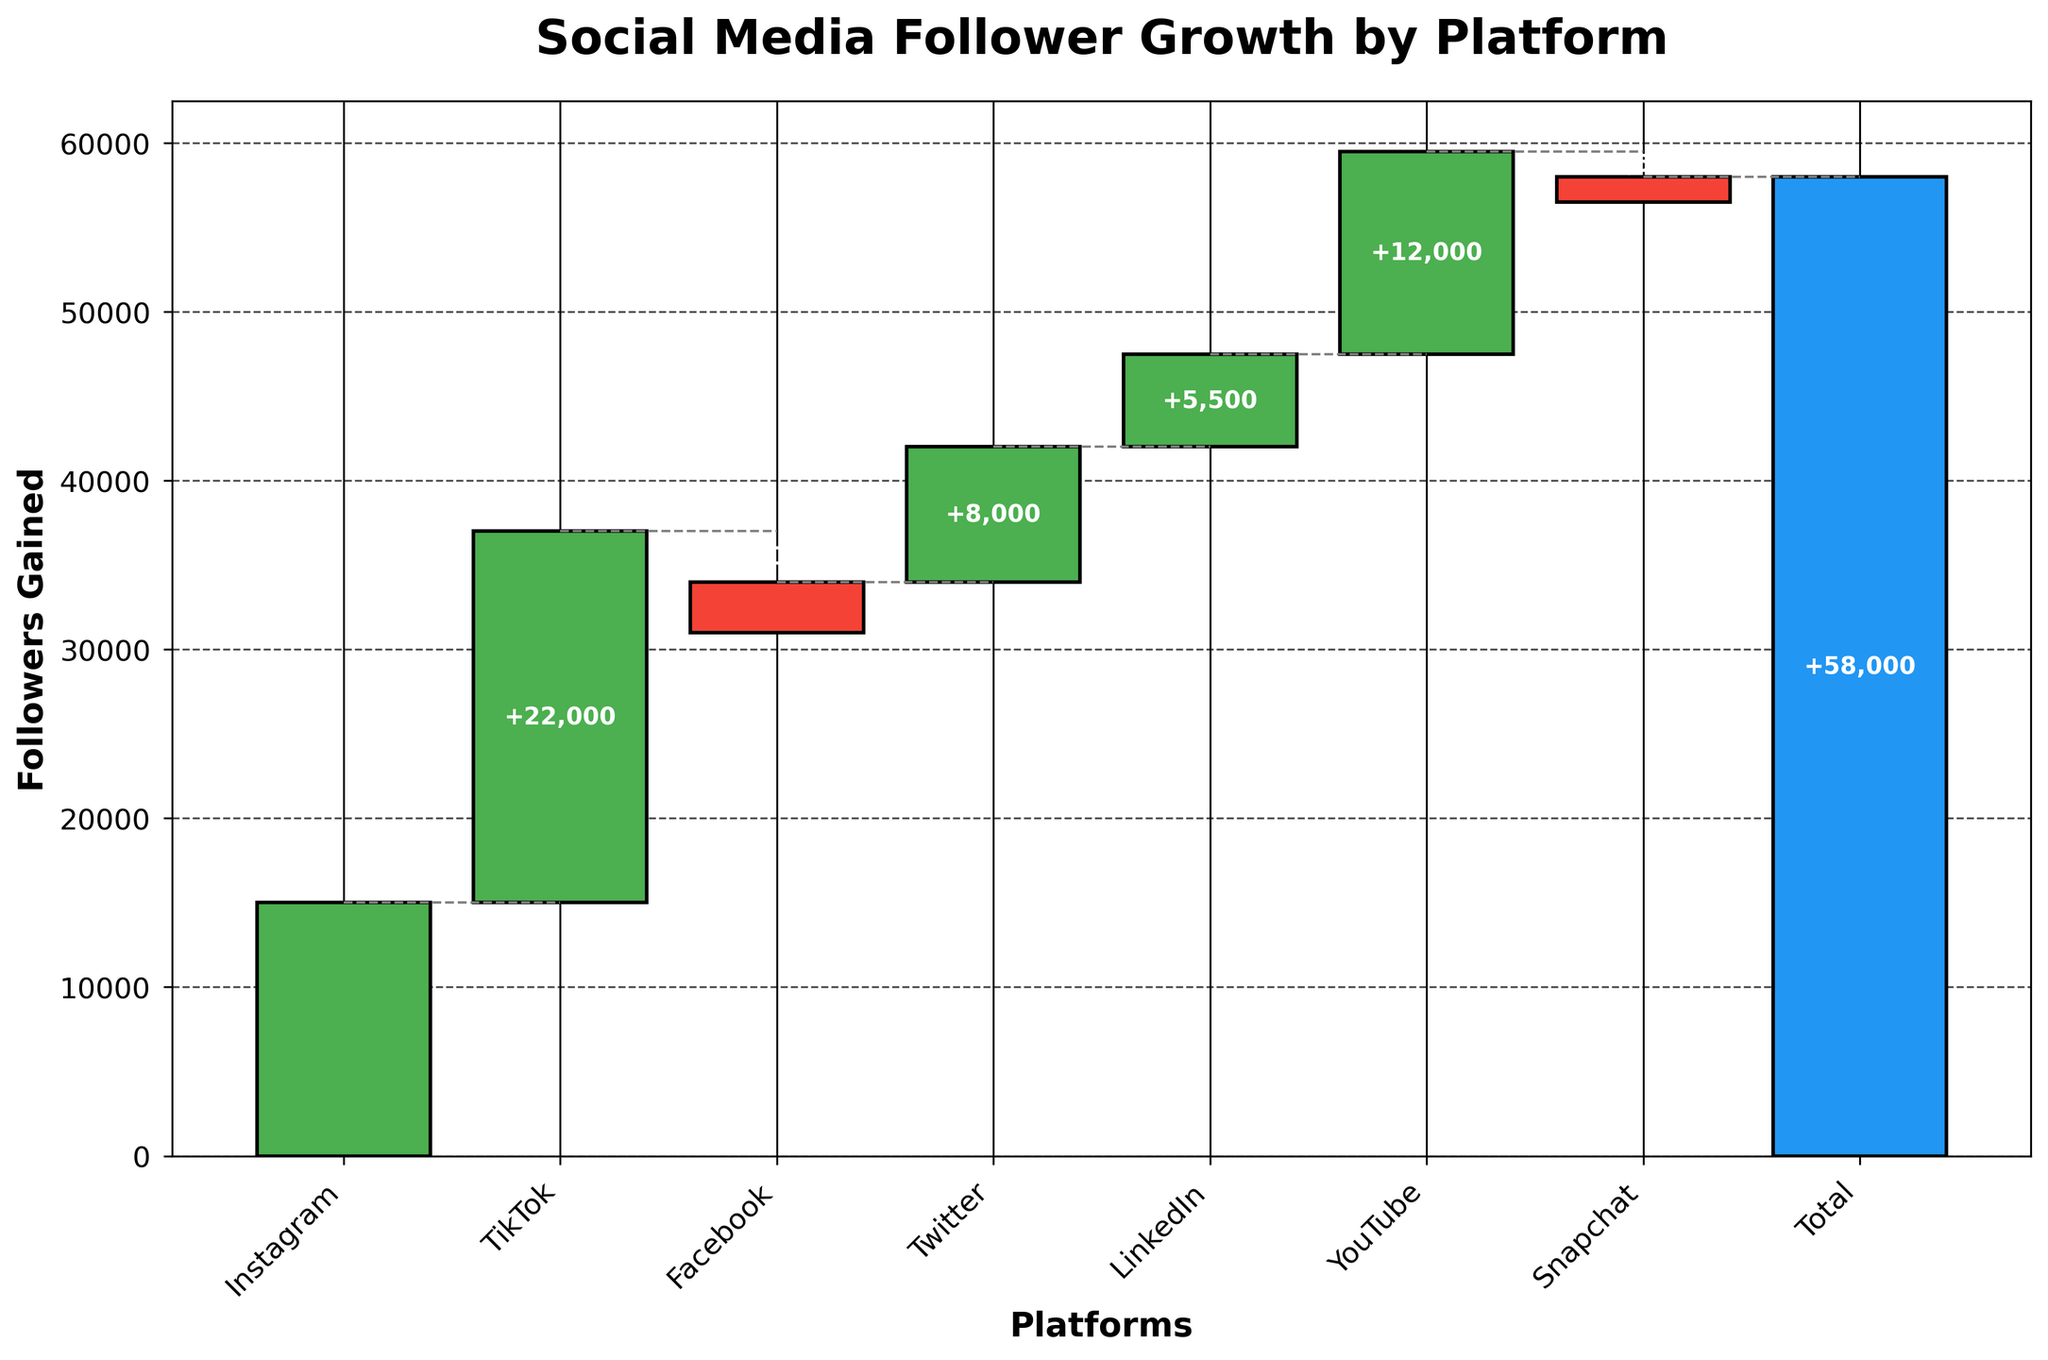What's the title of the figure? The title is usually displayed at the top of the figure. By looking at the figure, you can see that the title is written as "Social Media Follower Growth by Platform."
Answer: Social Media Follower Growth by Platform How many platforms are shown in the chart? Count the number of distinct bars shown for the platforms. Here, you have Instagram, TikTok, Facebook, Twitter, LinkedIn, YouTube, and Snapchat, along with the Total bar.
Answer: 7 Which platform had the highest follower growth? By observing the height of the bars, the tallest bar represents the highest follower growth. TikTok has the tallest bar with 22,000 followers gained.
Answer: TikTok Which platforms showed a decrease in the number of followers? Look for bars that go below the zero line. Facebook and Snapchat have bars extending below the zero line, indicating a decrease.
Answer: Facebook, Snapchat What’s the follower growth for YouTube? Identify the bar labeled "YouTube" and read the value next to it. YouTube shows a positive bar with a value of 12,000 followers gained.
Answer: 12,000 What's the combined follower growth for Instagram, TikTok, and Twitter? Add the values for Instagram (15,000), TikTok (22,000), and Twitter (8,000) together: 15,000 + 22,000 + 8,000 = 45,000.
Answer: 45,000 Which platform had the least positive follower growth, excluding those with a decrease? Compare the positive values for Instagram (15,000), TikTok (22,000), Twitter (8,000), LinkedIn (5,500), and YouTube (12,000). LinkedIn has the least positive growth with 5,500 followers.
Answer: LinkedIn What’s the total follower growth for all platforms combined? The total bar at the end summarizes all the follower changes across platforms, shown explicitly as 58,000.
Answer: 58,000 How much less is Facebook's follower growth compared to Instagram's? Subtract Facebook's value (-3,000) from Instagram's value (15,000). Convert the negative into a positive for the difference: 15,000 - (-3,000) = 15,000 + 3,000 = 18,000.
Answer: 18,000 What's the average follower growth for the platforms that showed an increase? Identify platforms with positive growth: Instagram (15,000), TikTok (22,000), Twitter (8,000), LinkedIn (5,500), YouTube (12,000). Calculate the average: (15,000 + 22,000 + 8,000 + 5,500 + 12,000) / 5 = 62,500 / 5 = 12,500.
Answer: 12,500 